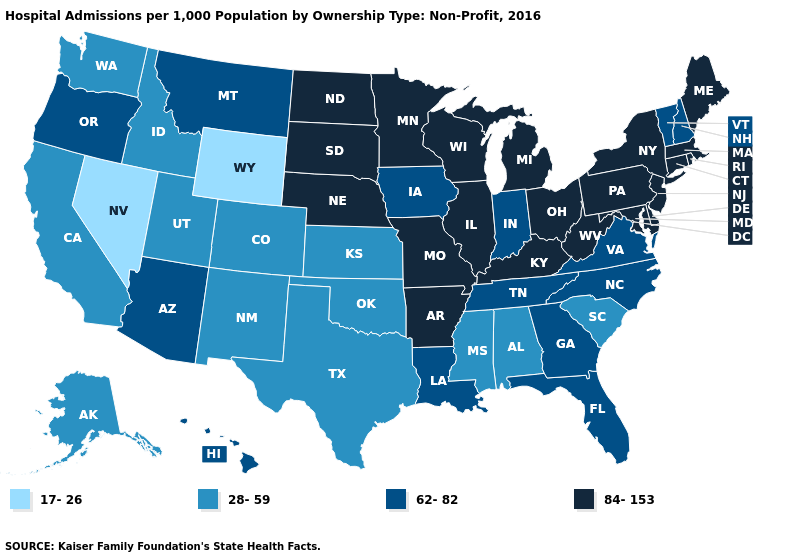What is the value of Hawaii?
Concise answer only. 62-82. Does New Hampshire have the lowest value in the USA?
Answer briefly. No. What is the value of Illinois?
Quick response, please. 84-153. What is the lowest value in the West?
Concise answer only. 17-26. Among the states that border Arizona , does California have the lowest value?
Be succinct. No. Does West Virginia have the highest value in the South?
Concise answer only. Yes. Does the map have missing data?
Give a very brief answer. No. What is the highest value in the USA?
Keep it brief. 84-153. Among the states that border Indiana , which have the highest value?
Concise answer only. Illinois, Kentucky, Michigan, Ohio. Does Mississippi have the same value as Alabama?
Short answer required. Yes. Name the states that have a value in the range 62-82?
Answer briefly. Arizona, Florida, Georgia, Hawaii, Indiana, Iowa, Louisiana, Montana, New Hampshire, North Carolina, Oregon, Tennessee, Vermont, Virginia. What is the value of West Virginia?
Answer briefly. 84-153. What is the highest value in the USA?
Quick response, please. 84-153. Among the states that border Idaho , does Utah have the highest value?
Write a very short answer. No. Which states have the lowest value in the Northeast?
Be succinct. New Hampshire, Vermont. 